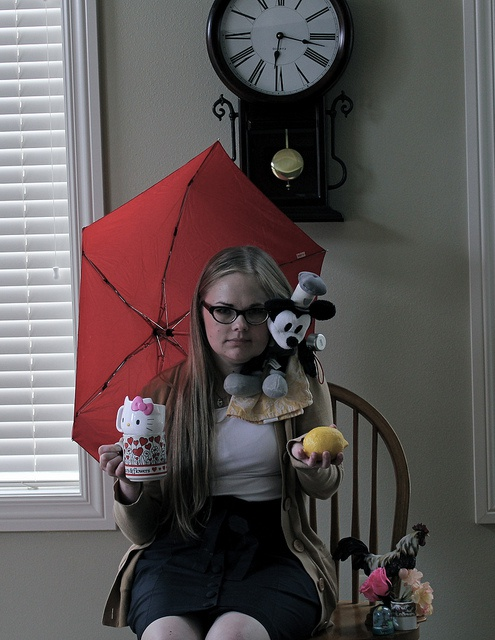Describe the objects in this image and their specific colors. I can see people in darkgray, black, gray, and maroon tones, umbrella in darkgray, brown, maroon, and black tones, chair in darkgray, gray, and black tones, clock in darkgray, gray, and black tones, and cup in darkgray, gray, black, and maroon tones in this image. 